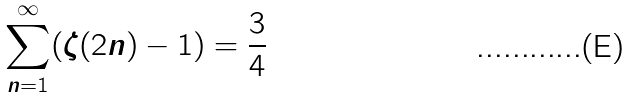<formula> <loc_0><loc_0><loc_500><loc_500>\sum _ { n = 1 } ^ { \infty } ( \zeta ( 2 n ) - 1 ) = \frac { 3 } { 4 }</formula> 